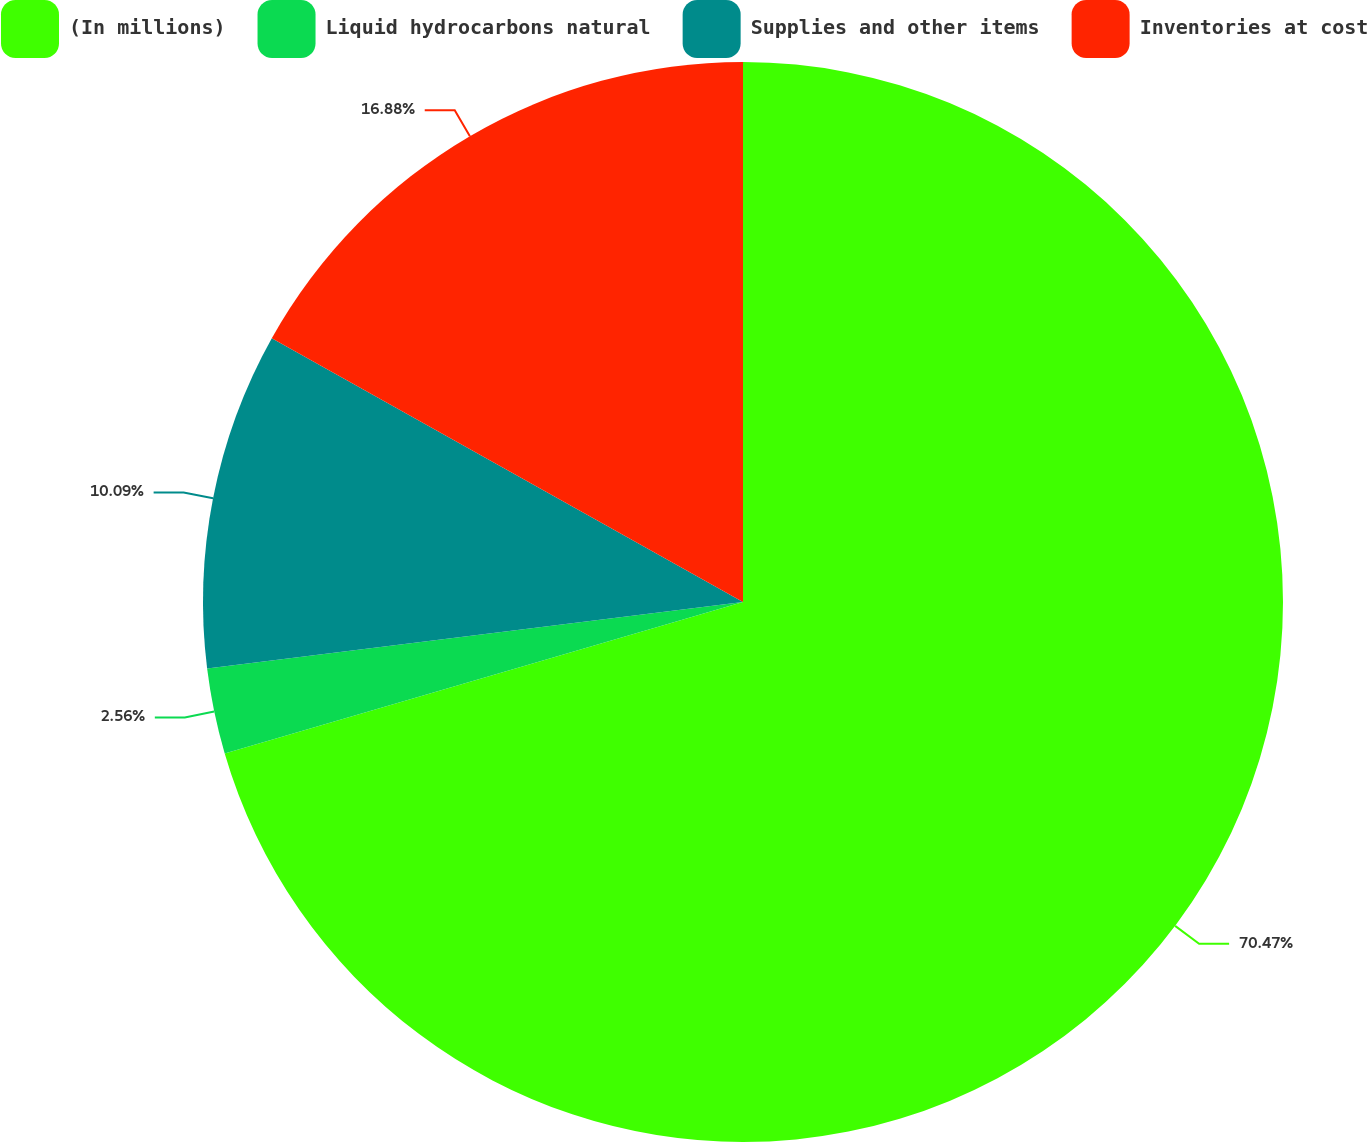Convert chart. <chart><loc_0><loc_0><loc_500><loc_500><pie_chart><fcel>(In millions)<fcel>Liquid hydrocarbons natural<fcel>Supplies and other items<fcel>Inventories at cost<nl><fcel>70.48%<fcel>2.56%<fcel>10.09%<fcel>16.88%<nl></chart> 